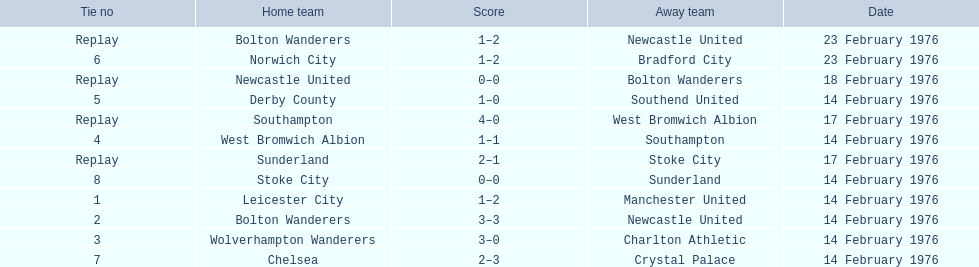What teams are featured in the game at the top of the table? Leicester City, Manchester United. Which of these two is the home team? Leicester City. 